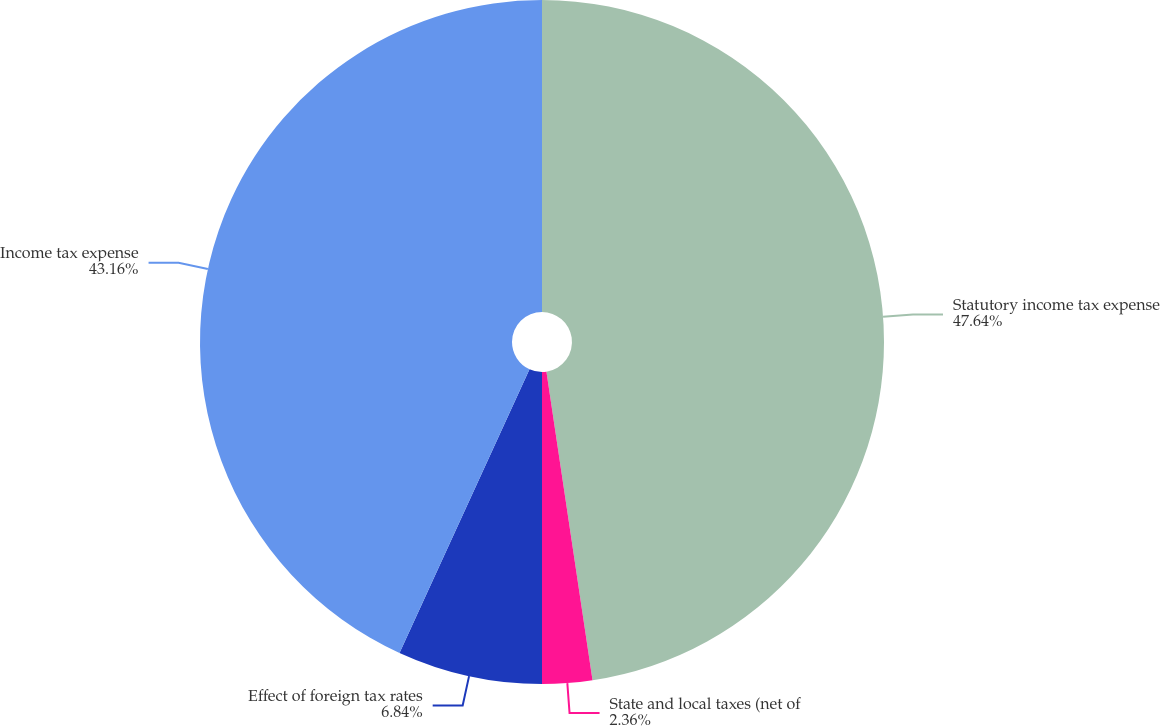<chart> <loc_0><loc_0><loc_500><loc_500><pie_chart><fcel>Statutory income tax expense<fcel>State and local taxes (net of<fcel>Effect of foreign tax rates<fcel>Income tax expense<nl><fcel>47.64%<fcel>2.36%<fcel>6.84%<fcel>43.16%<nl></chart> 